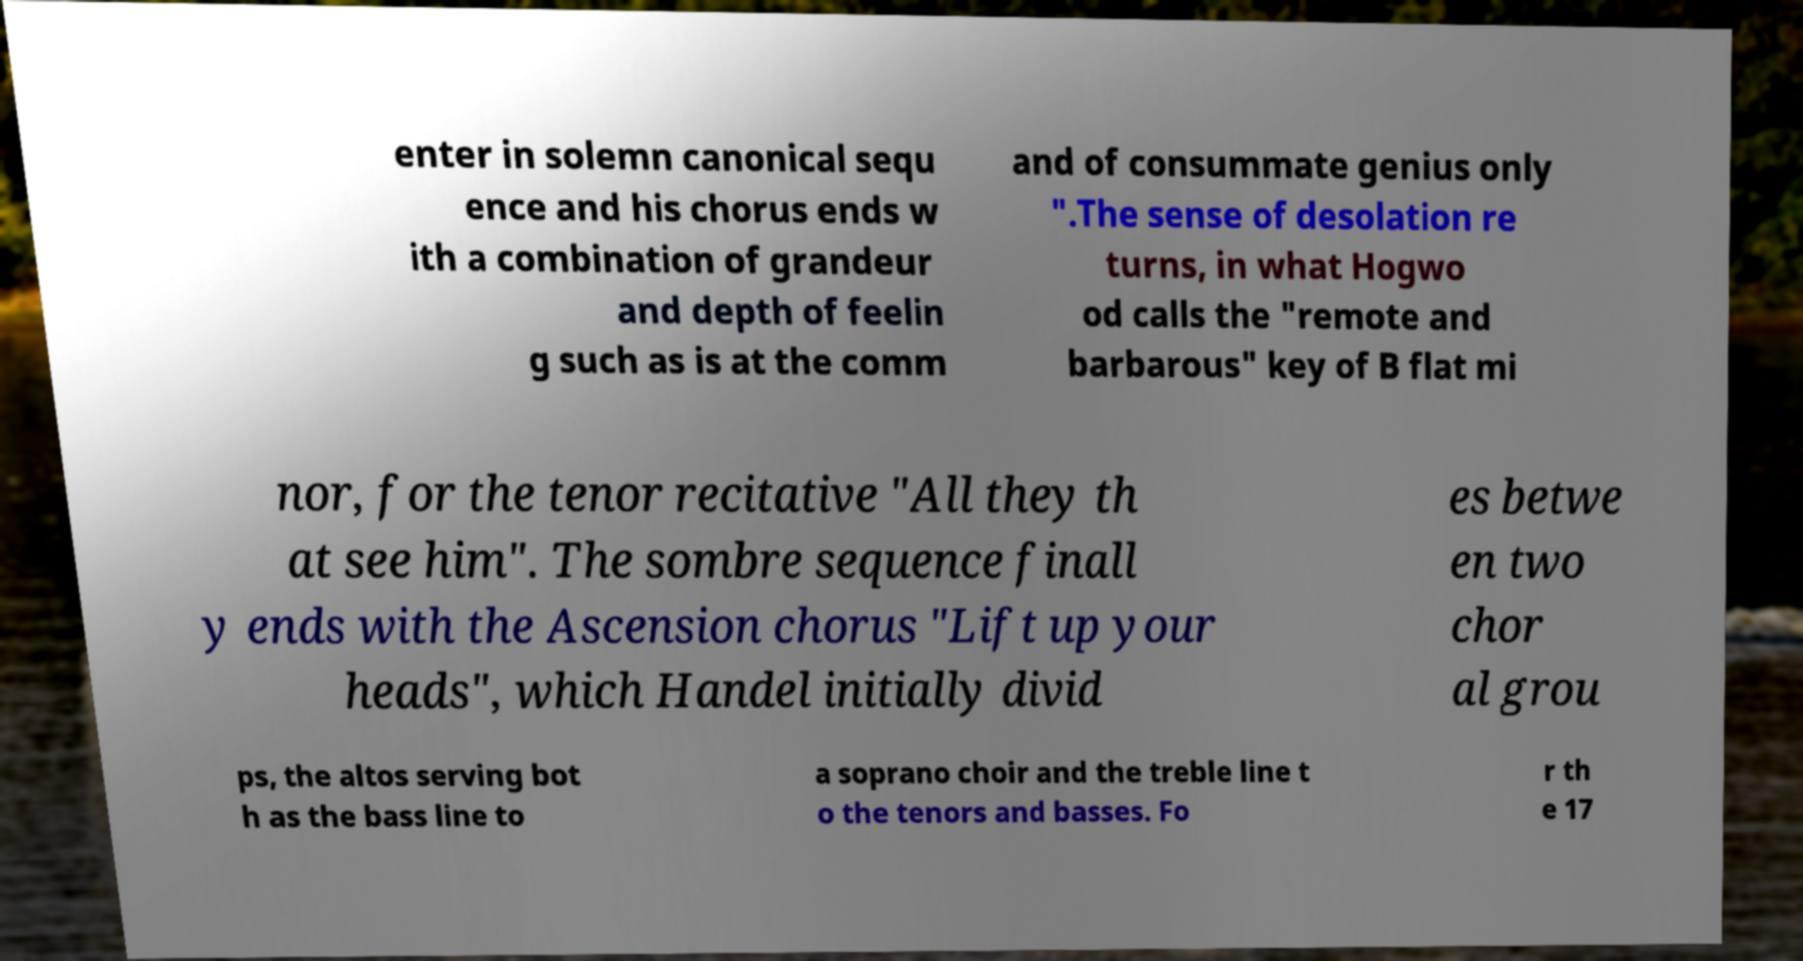Can you read and provide the text displayed in the image?This photo seems to have some interesting text. Can you extract and type it out for me? enter in solemn canonical sequ ence and his chorus ends w ith a combination of grandeur and depth of feelin g such as is at the comm and of consummate genius only ".The sense of desolation re turns, in what Hogwo od calls the "remote and barbarous" key of B flat mi nor, for the tenor recitative "All they th at see him". The sombre sequence finall y ends with the Ascension chorus "Lift up your heads", which Handel initially divid es betwe en two chor al grou ps, the altos serving bot h as the bass line to a soprano choir and the treble line t o the tenors and basses. Fo r th e 17 